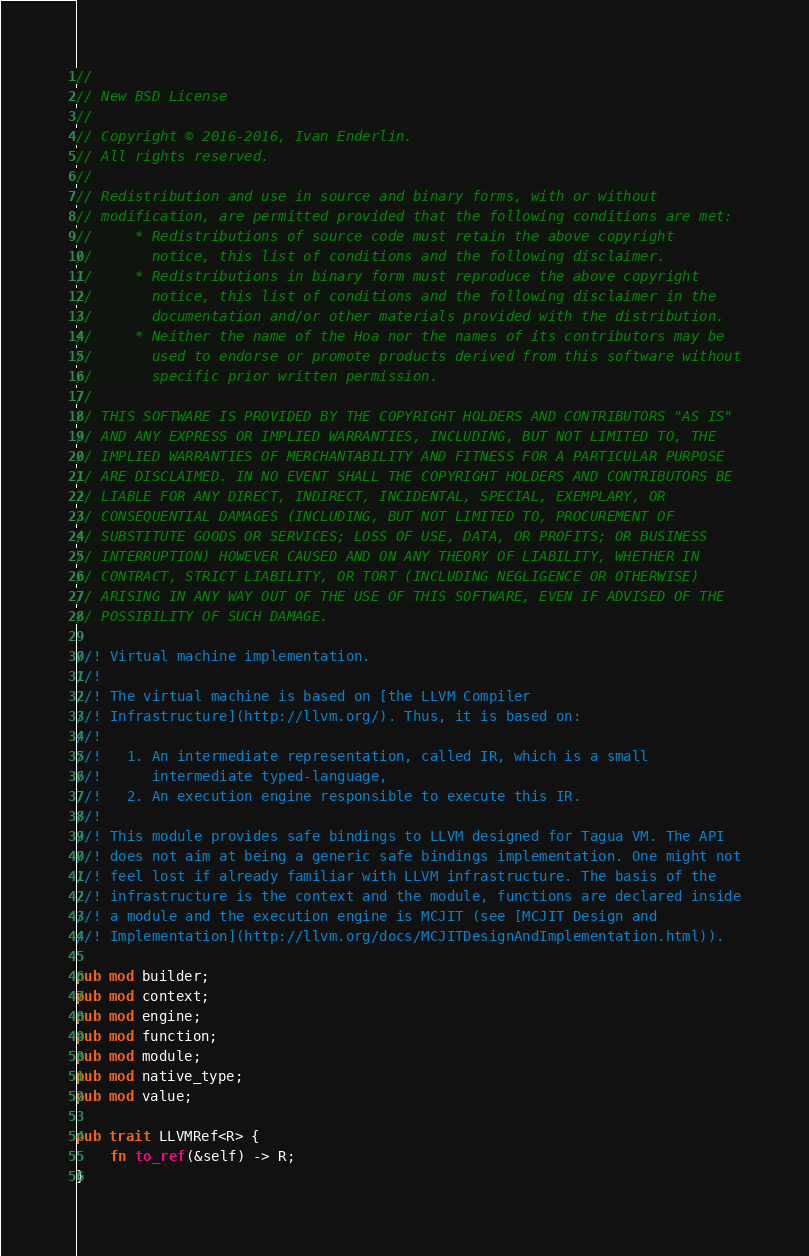<code> <loc_0><loc_0><loc_500><loc_500><_Rust_>//
// New BSD License
//
// Copyright © 2016-2016, Ivan Enderlin.
// All rights reserved.
//
// Redistribution and use in source and binary forms, with or without
// modification, are permitted provided that the following conditions are met:
//     * Redistributions of source code must retain the above copyright
//       notice, this list of conditions and the following disclaimer.
//     * Redistributions in binary form must reproduce the above copyright
//       notice, this list of conditions and the following disclaimer in the
//       documentation and/or other materials provided with the distribution.
//     * Neither the name of the Hoa nor the names of its contributors may be
//       used to endorse or promote products derived from this software without
//       specific prior written permission.
//
// THIS SOFTWARE IS PROVIDED BY THE COPYRIGHT HOLDERS AND CONTRIBUTORS "AS IS"
// AND ANY EXPRESS OR IMPLIED WARRANTIES, INCLUDING, BUT NOT LIMITED TO, THE
// IMPLIED WARRANTIES OF MERCHANTABILITY AND FITNESS FOR A PARTICULAR PURPOSE
// ARE DISCLAIMED. IN NO EVENT SHALL THE COPYRIGHT HOLDERS AND CONTRIBUTORS BE
// LIABLE FOR ANY DIRECT, INDIRECT, INCIDENTAL, SPECIAL, EXEMPLARY, OR
// CONSEQUENTIAL DAMAGES (INCLUDING, BUT NOT LIMITED TO, PROCUREMENT OF
// SUBSTITUTE GOODS OR SERVICES; LOSS OF USE, DATA, OR PROFITS; OR BUSINESS
// INTERRUPTION) HOWEVER CAUSED AND ON ANY THEORY OF LIABILITY, WHETHER IN
// CONTRACT, STRICT LIABILITY, OR TORT (INCLUDING NEGLIGENCE OR OTHERWISE)
// ARISING IN ANY WAY OUT OF THE USE OF THIS SOFTWARE, EVEN IF ADVISED OF THE
// POSSIBILITY OF SUCH DAMAGE.

//! Virtual machine implementation.
//!
//! The virtual machine is based on [the LLVM Compiler
//! Infrastructure](http://llvm.org/). Thus, it is based on:
//!
//!   1. An intermediate representation, called IR, which is a small
//!      intermediate typed-language,
//!   2. An execution engine responsible to execute this IR.
//!
//! This module provides safe bindings to LLVM designed for Tagua VM. The API
//! does not aim at being a generic safe bindings implementation. One might not
//! feel lost if already familiar with LLVM infrastructure. The basis of the
//! infrastructure is the context and the module, functions are declared inside
//! a module and the execution engine is MCJIT (see [MCJIT Design and
//! Implementation](http://llvm.org/docs/MCJITDesignAndImplementation.html)).

pub mod builder;
pub mod context;
pub mod engine;
pub mod function;
pub mod module;
pub mod native_type;
pub mod value;

pub trait LLVMRef<R> {
    fn to_ref(&self) -> R;
}
</code> 